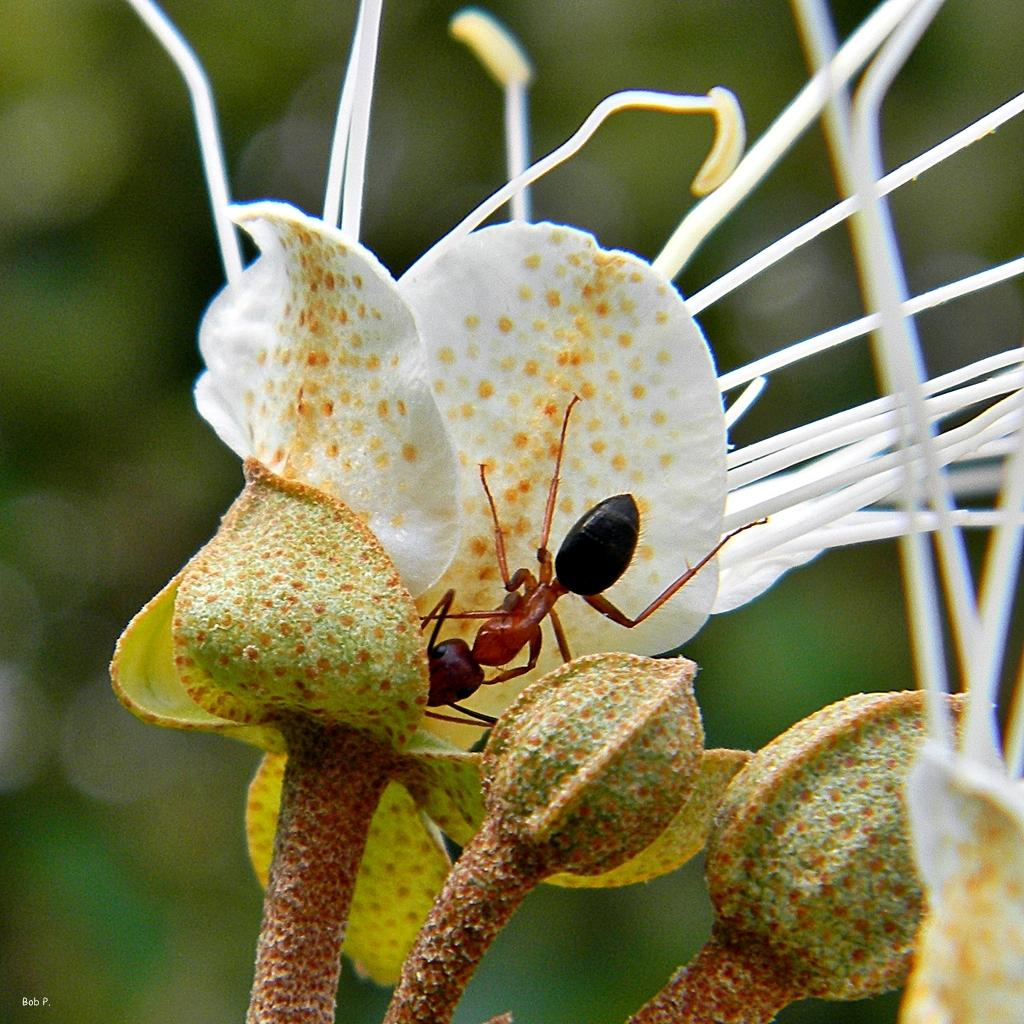What is the main subject of the image? There is an ant in the image. Where is the ant located? The ant is on a flower. Can you describe the background of the image? The background of the image is blurred. What word is written on the stone in the image? There is no stone or word present in the image; it features an ant on a flower with a blurred background. 